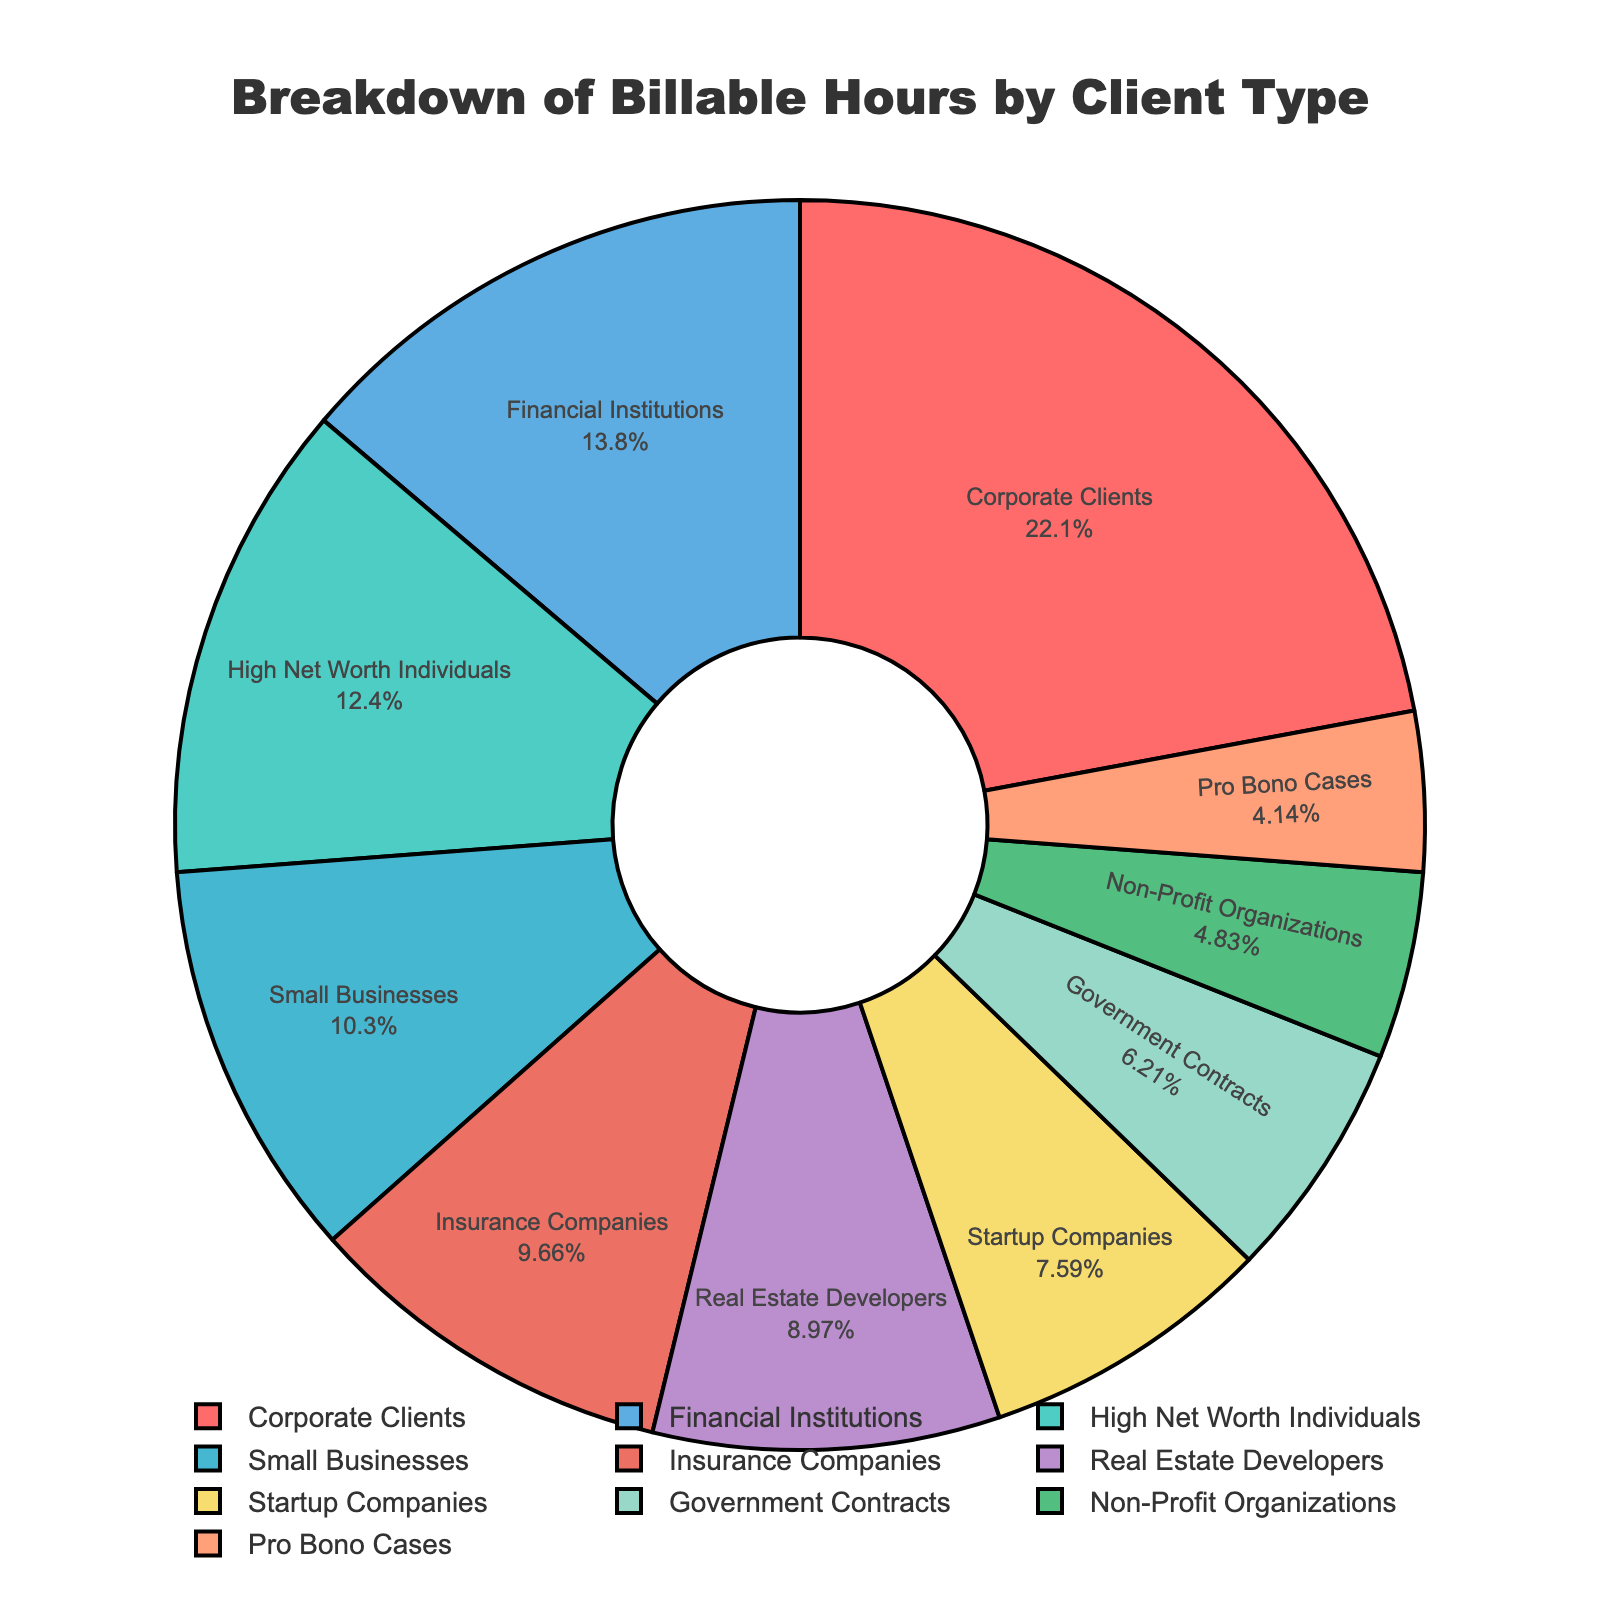Which client type has the highest percentage of billable hours? The pie chart shows the breakdown of billable hours by client type, with Corporate Clients having the largest segment.
Answer: Corporate Clients What is the difference in billable hours between Corporate Clients and Pro Bono Cases? Corporate Clients have 320 billable hours and Pro Bono Cases have 60 billable hours. The difference is 320 - 60 = 260.
Answer: 260 Which client type has more billable hours: Startup Companies or High Net Worth Individuals? The pie chart shows that High Net Worth Individuals have 180 billable hours, while Startup Companies have 110 billable hours. Thus, High Net Worth Individuals have more billable hours.
Answer: High Net Worth Individuals What is the combined percentage of billable hours for Government Contracts and Real Estate Developers? The pie chart segments representing Government Contracts and Real Estate Developers need to be added together. Government Contracts have 90 hours and Real Estate Developers have 130 hours. The total billable hours for all clients are 1450. The combined percentage is (90 + 130) / 1450 * 100 = 15.17%.
Answer: 15.17% Are the billable hours for Insurance Companies greater or less than those for Financial Institutions? The pie chart shows that Financial Institutions have 200 billable hours, while Insurance Companies have 140 billable hours. Therefore, billable hours for Insurance Companies are less.
Answer: Less How does the percentage of billable hours for Small Businesses compare to that for Non-Profit Organizations? Small Businesses have 150 billable hours, and Non-Profit Organizations have 70 billable hours. The total billable hours are 1450. The percentage for Small Businesses is (150 / 1450 * 100) ≈ 10.34%, and for Non-Profit Organizations is (70 / 1450 * 100) ≈ 4.83%. Small Businesses have a higher percentage.
Answer: Higher What is the percentage of total billable hours worked for Financial Institutions? Financial Institutions have 200 billable hours out of a total of 1450 hours. The percentage is (200 / 1450 * 100) ≈ 13.79%.
Answer: 13.79% What is the total percentage of billable hours for clients other than Corporate Clients and Financial Institutions? Subtract the combined percentage of Corporate Clients (22.07%) and Financial Institutions (13.79%) from 100%. The total percentage for other clients is 100 - (22.07 + 13.79) ≈ 64.14%.
Answer: 64.14% Which client type shares the same color as Small Businesses? By visually inspecting the pie chart and the color legend, you can see that Pro Bono Cases share the same color as Small Businesses.
Answer: Pro Bono Cases What is the approximate ratio of billable hours between High Net Worth Individuals and Real Estate Developers? High Net Worth Individuals have 180 billable hours, and Real Estate Developers have 130 billable hours. The ratio is 180:130, which simplifies to approximately 9:6.5 or 1.38:1.
Answer: 1.38:1 